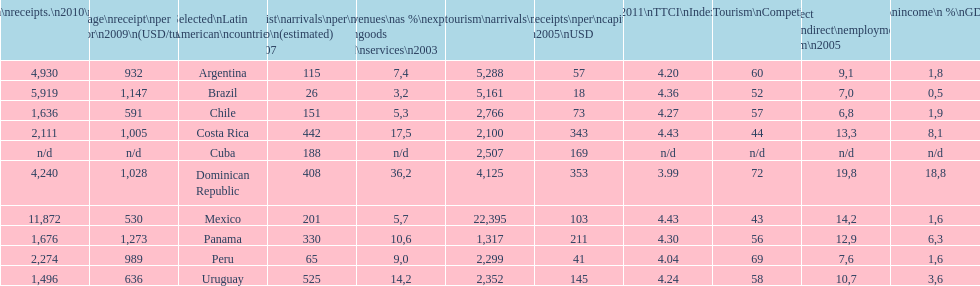What is the name of the country that had the most international tourism arrivals in 2010? Mexico. 